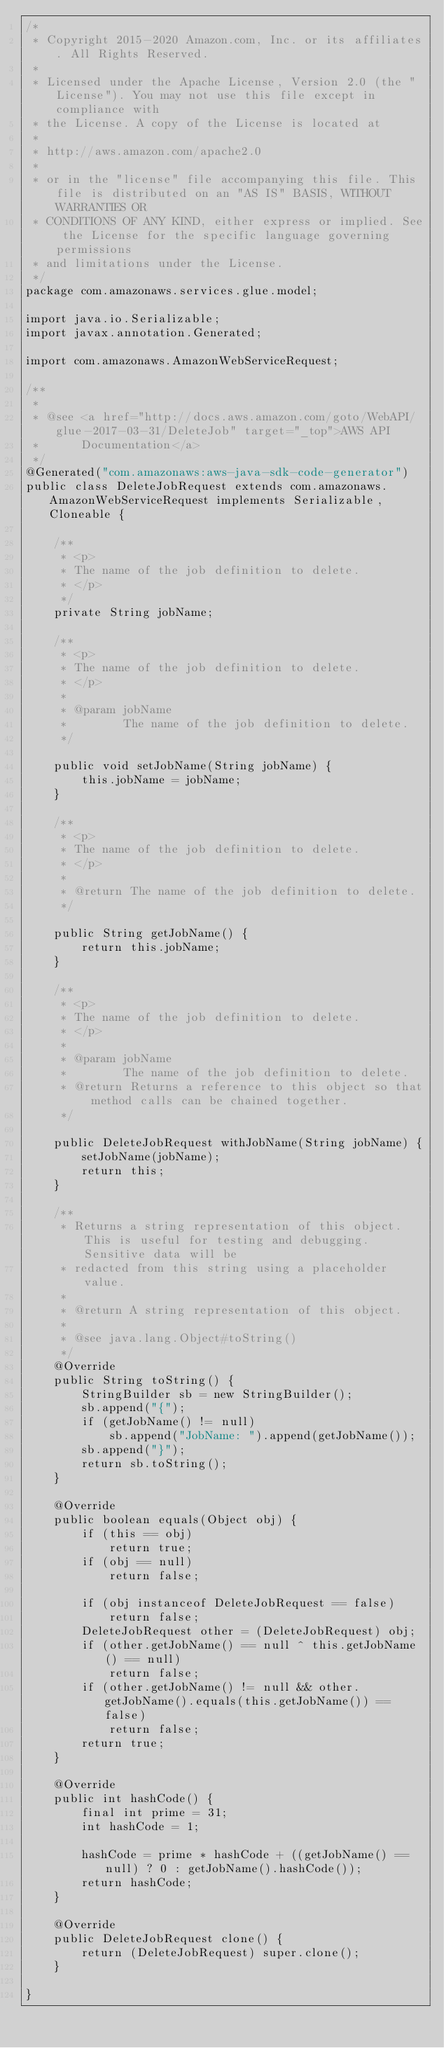<code> <loc_0><loc_0><loc_500><loc_500><_Java_>/*
 * Copyright 2015-2020 Amazon.com, Inc. or its affiliates. All Rights Reserved.
 * 
 * Licensed under the Apache License, Version 2.0 (the "License"). You may not use this file except in compliance with
 * the License. A copy of the License is located at
 * 
 * http://aws.amazon.com/apache2.0
 * 
 * or in the "license" file accompanying this file. This file is distributed on an "AS IS" BASIS, WITHOUT WARRANTIES OR
 * CONDITIONS OF ANY KIND, either express or implied. See the License for the specific language governing permissions
 * and limitations under the License.
 */
package com.amazonaws.services.glue.model;

import java.io.Serializable;
import javax.annotation.Generated;

import com.amazonaws.AmazonWebServiceRequest;

/**
 * 
 * @see <a href="http://docs.aws.amazon.com/goto/WebAPI/glue-2017-03-31/DeleteJob" target="_top">AWS API
 *      Documentation</a>
 */
@Generated("com.amazonaws:aws-java-sdk-code-generator")
public class DeleteJobRequest extends com.amazonaws.AmazonWebServiceRequest implements Serializable, Cloneable {

    /**
     * <p>
     * The name of the job definition to delete.
     * </p>
     */
    private String jobName;

    /**
     * <p>
     * The name of the job definition to delete.
     * </p>
     * 
     * @param jobName
     *        The name of the job definition to delete.
     */

    public void setJobName(String jobName) {
        this.jobName = jobName;
    }

    /**
     * <p>
     * The name of the job definition to delete.
     * </p>
     * 
     * @return The name of the job definition to delete.
     */

    public String getJobName() {
        return this.jobName;
    }

    /**
     * <p>
     * The name of the job definition to delete.
     * </p>
     * 
     * @param jobName
     *        The name of the job definition to delete.
     * @return Returns a reference to this object so that method calls can be chained together.
     */

    public DeleteJobRequest withJobName(String jobName) {
        setJobName(jobName);
        return this;
    }

    /**
     * Returns a string representation of this object. This is useful for testing and debugging. Sensitive data will be
     * redacted from this string using a placeholder value.
     *
     * @return A string representation of this object.
     *
     * @see java.lang.Object#toString()
     */
    @Override
    public String toString() {
        StringBuilder sb = new StringBuilder();
        sb.append("{");
        if (getJobName() != null)
            sb.append("JobName: ").append(getJobName());
        sb.append("}");
        return sb.toString();
    }

    @Override
    public boolean equals(Object obj) {
        if (this == obj)
            return true;
        if (obj == null)
            return false;

        if (obj instanceof DeleteJobRequest == false)
            return false;
        DeleteJobRequest other = (DeleteJobRequest) obj;
        if (other.getJobName() == null ^ this.getJobName() == null)
            return false;
        if (other.getJobName() != null && other.getJobName().equals(this.getJobName()) == false)
            return false;
        return true;
    }

    @Override
    public int hashCode() {
        final int prime = 31;
        int hashCode = 1;

        hashCode = prime * hashCode + ((getJobName() == null) ? 0 : getJobName().hashCode());
        return hashCode;
    }

    @Override
    public DeleteJobRequest clone() {
        return (DeleteJobRequest) super.clone();
    }

}
</code> 